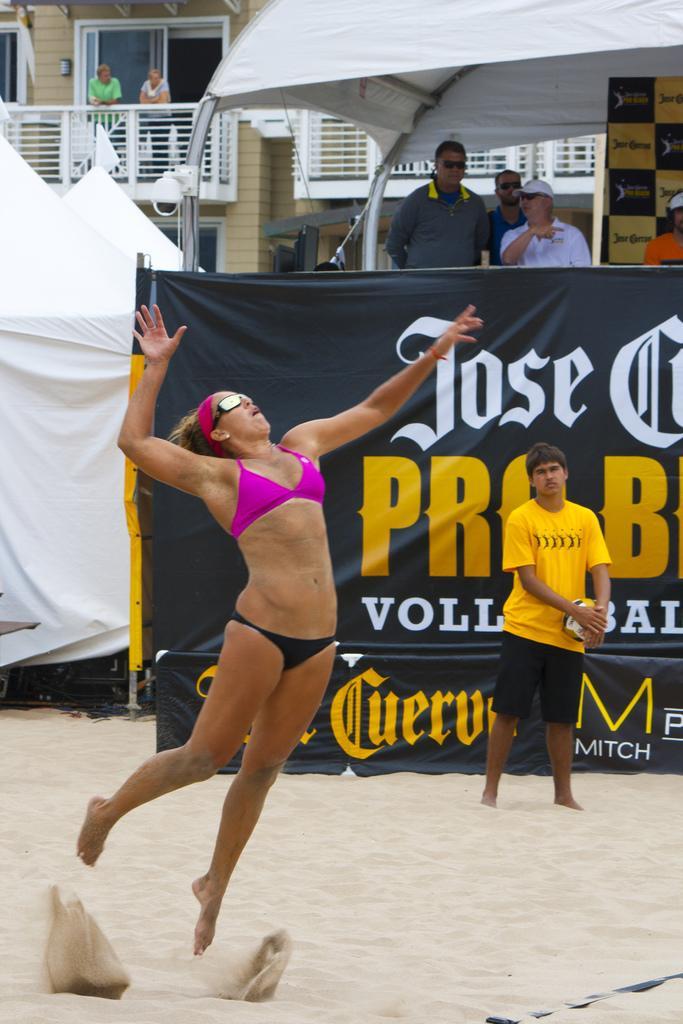Describe this image in one or two sentences. In the image a woman is playing volleyball, she is jumping in the air and behind her there is a banner and few other people were standing around that banner, in the background there is a building and two other people were standing in the building´s balcony. 